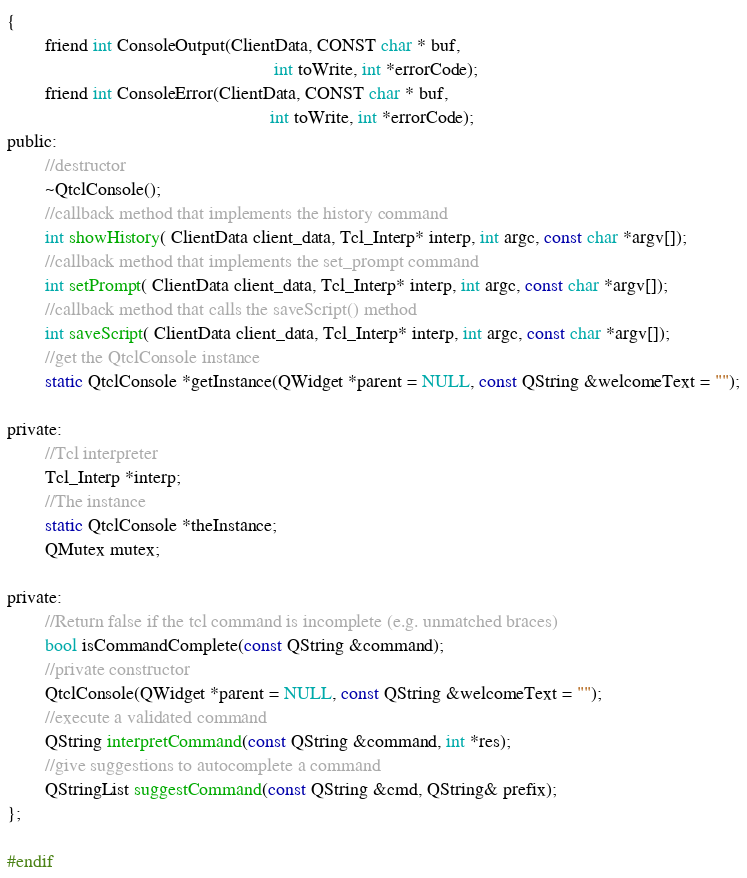<code> <loc_0><loc_0><loc_500><loc_500><_C_>{
		friend int ConsoleOutput(ClientData, CONST char * buf,
														 int toWrite, int *errorCode);
		friend int ConsoleError(ClientData, CONST char * buf,
														int toWrite, int *errorCode);
public:
		//destructor
		~QtclConsole();
		//callback method that implements the history command
		int showHistory( ClientData client_data, Tcl_Interp* interp, int argc, const char *argv[]);
		//callback method that implements the set_prompt command
		int setPrompt( ClientData client_data, Tcl_Interp* interp, int argc, const char *argv[]);
		//callback method that calls the saveScript() method
		int saveScript( ClientData client_data, Tcl_Interp* interp, int argc, const char *argv[]);
		//get the QtclConsole instance
		static QtclConsole *getInstance(QWidget *parent = NULL, const QString &welcomeText = "");

private:
		//Tcl interpreter
		Tcl_Interp *interp;
		//The instance
		static QtclConsole *theInstance;
		QMutex mutex;

private:
		//Return false if the tcl command is incomplete (e.g. unmatched braces)
		bool isCommandComplete(const QString &command);
		//private constructor
		QtclConsole(QWidget *parent = NULL, const QString &welcomeText = "");
		//execute a validated command
		QString interpretCommand(const QString &command, int *res);
		//give suggestions to autocomplete a command
		QStringList suggestCommand(const QString &cmd, QString& prefix);
};

#endif
</code> 